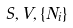<formula> <loc_0><loc_0><loc_500><loc_500>S , V , \{ N _ { i } \}</formula> 